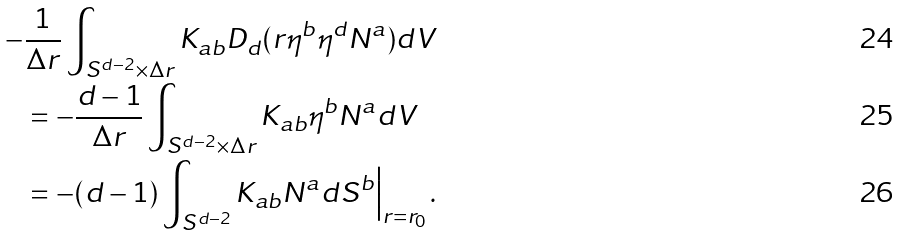<formula> <loc_0><loc_0><loc_500><loc_500>- & \frac { 1 } { \Delta r } \int _ { S ^ { d - 2 } \times \Delta r } K _ { a b } D _ { d } ( r \eta ^ { b } \eta ^ { d } N ^ { a } ) d V \\ & = - \frac { d - 1 } { \Delta r } \int _ { S ^ { d - 2 } \times \Delta r } K _ { a b } \eta ^ { b } N ^ { a } d V \\ & = - ( d - 1 ) \int _ { S ^ { d - 2 } } K _ { a b } N ^ { a } d S ^ { b } \Big | _ { r = r _ { 0 } } \, .</formula> 